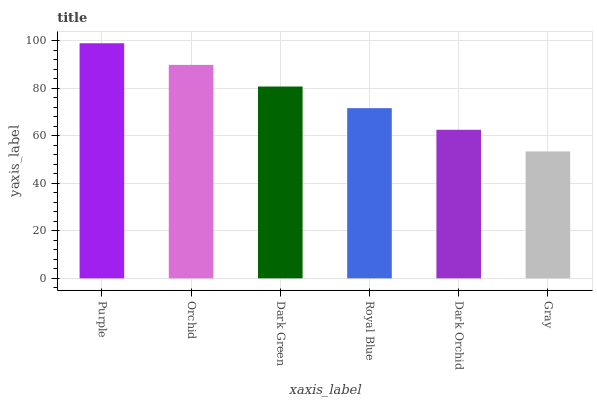Is Gray the minimum?
Answer yes or no. Yes. Is Purple the maximum?
Answer yes or no. Yes. Is Orchid the minimum?
Answer yes or no. No. Is Orchid the maximum?
Answer yes or no. No. Is Purple greater than Orchid?
Answer yes or no. Yes. Is Orchid less than Purple?
Answer yes or no. Yes. Is Orchid greater than Purple?
Answer yes or no. No. Is Purple less than Orchid?
Answer yes or no. No. Is Dark Green the high median?
Answer yes or no. Yes. Is Royal Blue the low median?
Answer yes or no. Yes. Is Purple the high median?
Answer yes or no. No. Is Dark Green the low median?
Answer yes or no. No. 